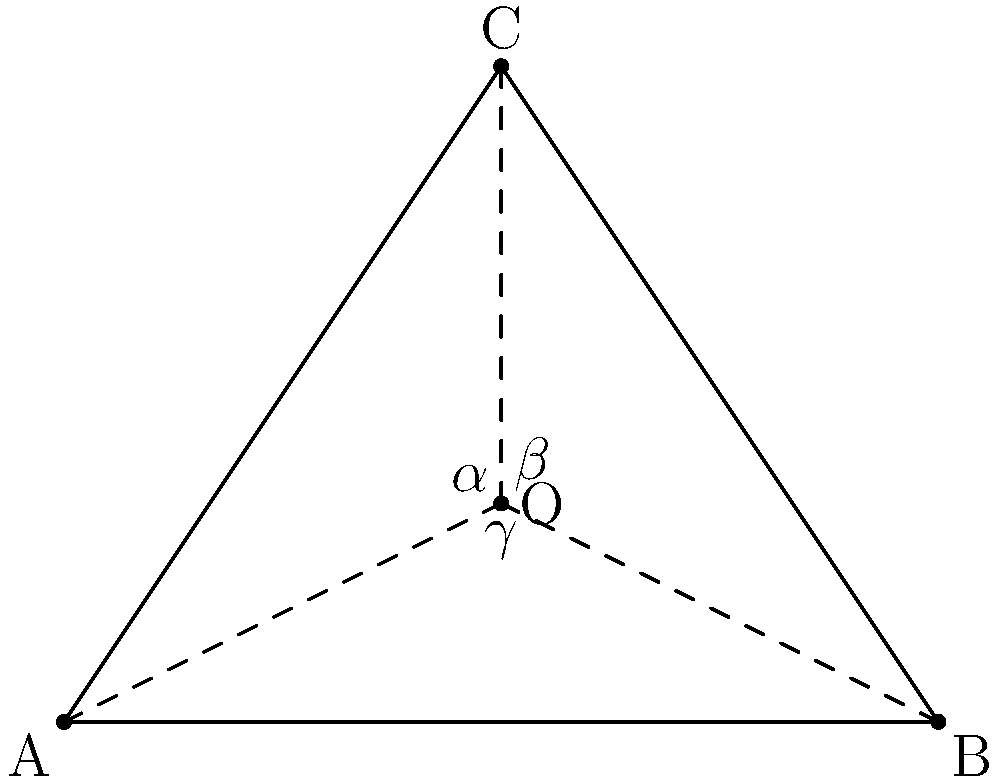Three witnesses at locations A, B, and C report sighting an unidentified flying object at point O. Given that ∠AOB = $\alpha$, ∠BOC = $\beta$, and ∠COA = $\gamma$, what is the sum of these angles in terms of $\pi$? Let's approach this step-by-step:

1) In any triangle, the sum of all interior angles is always $\pi$ radians or 180°.

2) The triangle ABC is divided into three smaller triangles: AOB, BOC, and COA.

3) The angles $\alpha$, $\beta$, and $\gamma$ are the exterior angles of these smaller triangles at point O.

4) For any triangle, an exterior angle is supplementary to the sum of the two non-adjacent interior angles. This means:

   For triangle AOB: $\alpha + $ (sum of interior angles at A and B) = $\pi$
   For triangle BOC: $\beta + $ (sum of interior angles at B and C) = $\pi$
   For triangle COA: $\gamma + $ (sum of interior angles at C and A) = $\pi$

5) Adding these three equations:

   $\alpha + \beta + \gamma + $ (sum of all interior angles of triangle ABC) = $3\pi$

6) We know the sum of all interior angles of triangle ABC is $\pi$, so:

   $\alpha + \beta + \gamma + \pi = 3\pi$

7) Subtracting $\pi$ from both sides:

   $\alpha + \beta + \gamma = 2\pi$

Therefore, the sum of angles $\alpha$, $\beta$, and $\gamma$ is $2\pi$ radians or 360°.
Answer: $2\pi$ 